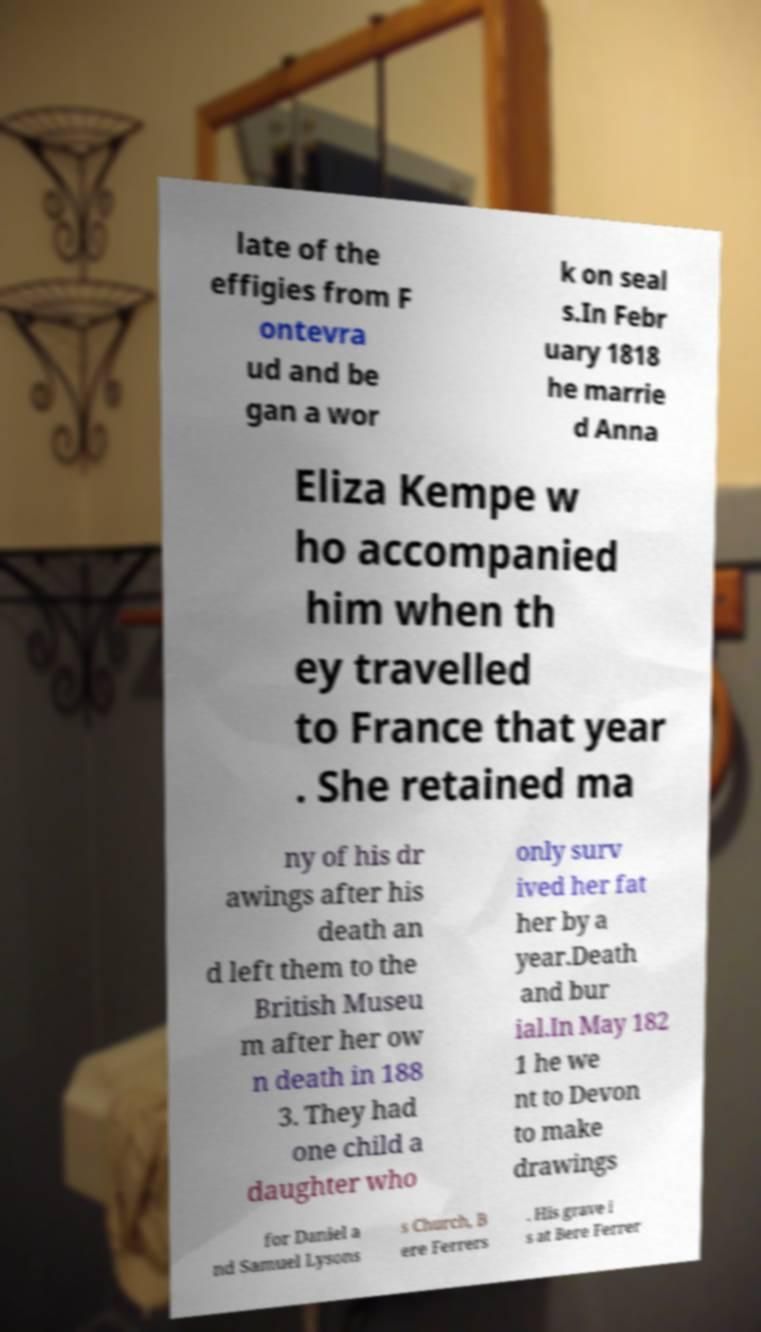For documentation purposes, I need the text within this image transcribed. Could you provide that? late of the effigies from F ontevra ud and be gan a wor k on seal s.In Febr uary 1818 he marrie d Anna Eliza Kempe w ho accompanied him when th ey travelled to France that year . She retained ma ny of his dr awings after his death an d left them to the British Museu m after her ow n death in 188 3. They had one child a daughter who only surv ived her fat her by a year.Death and bur ial.In May 182 1 he we nt to Devon to make drawings for Daniel a nd Samuel Lysons s Church, B ere Ferrers . His grave i s at Bere Ferrer 